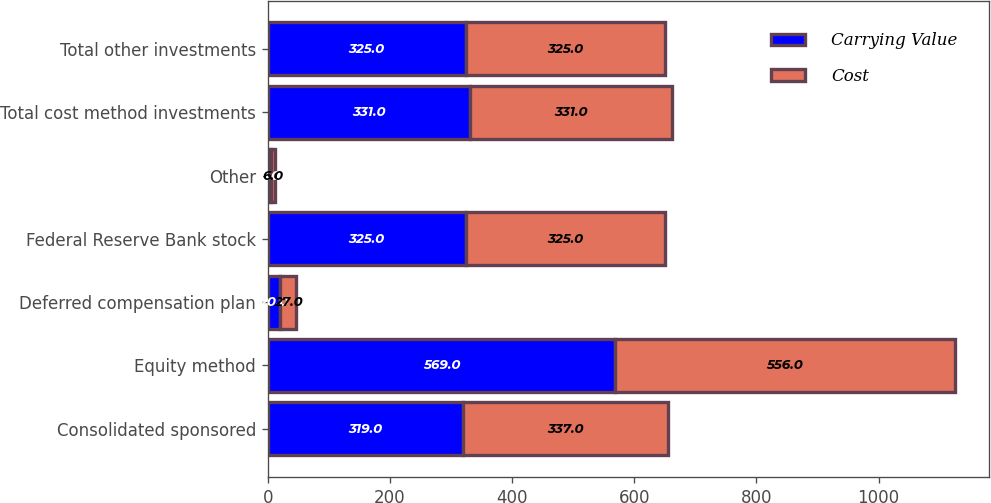<chart> <loc_0><loc_0><loc_500><loc_500><stacked_bar_chart><ecel><fcel>Consolidated sponsored<fcel>Equity method<fcel>Deferred compensation plan<fcel>Federal Reserve Bank stock<fcel>Other<fcel>Total cost method investments<fcel>Total other investments<nl><fcel>Carrying Value<fcel>319<fcel>569<fcel>20<fcel>325<fcel>6<fcel>331<fcel>325<nl><fcel>Cost<fcel>337<fcel>556<fcel>27<fcel>325<fcel>6<fcel>331<fcel>325<nl></chart> 